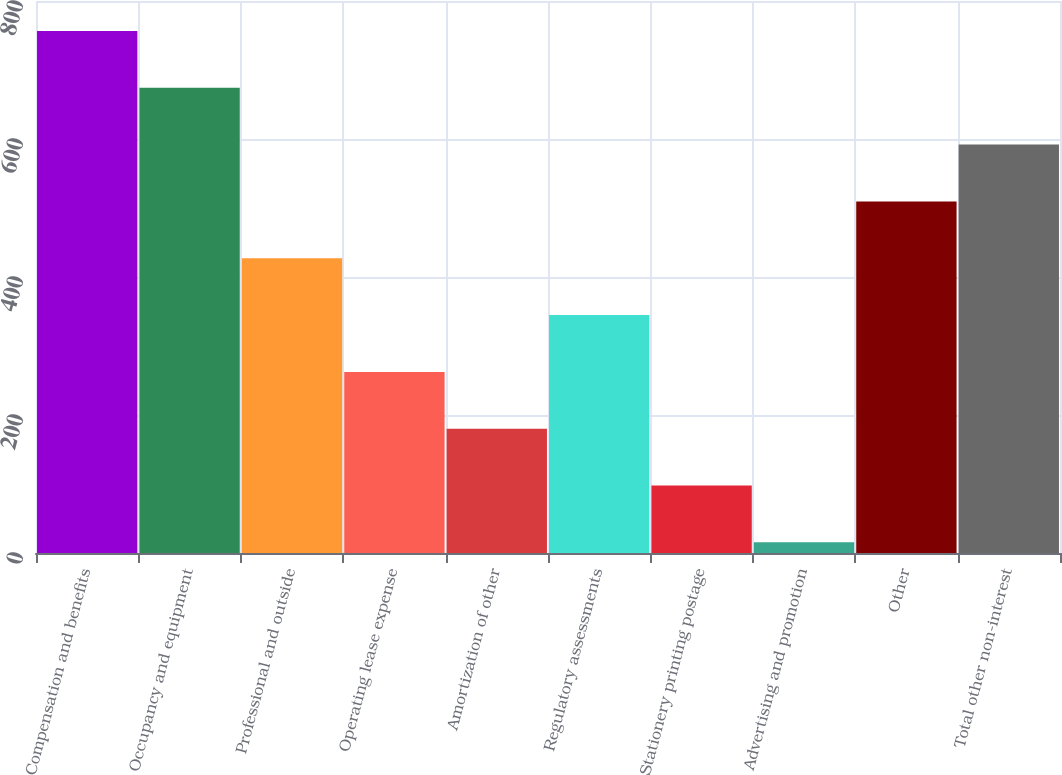<chart> <loc_0><loc_0><loc_500><loc_500><bar_chart><fcel>Compensation and benefits<fcel>Occupancy and equipment<fcel>Professional and outside<fcel>Operating lease expense<fcel>Amortization of other<fcel>Regulatory assessments<fcel>Stationery printing postage<fcel>Advertising and promotion<fcel>Other<fcel>Total other non-interest<nl><fcel>756.64<fcel>674.28<fcel>427.2<fcel>262.48<fcel>180.12<fcel>344.84<fcel>97.76<fcel>15.4<fcel>509.56<fcel>591.92<nl></chart> 